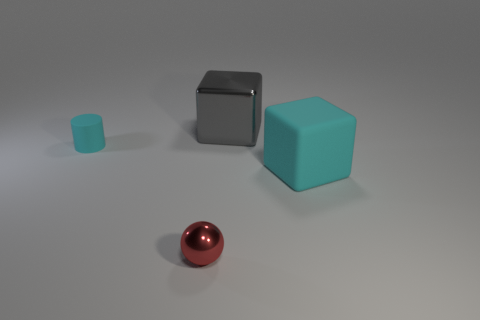What number of other things are the same color as the tiny metal ball?
Offer a terse response. 0. There is a object that is both on the right side of the small rubber cylinder and behind the rubber cube; what is its color?
Your response must be concise. Gray. There is a metallic thing that is right of the metal thing that is to the left of the big thing that is to the left of the big matte thing; what size is it?
Your response must be concise. Large. How many things are either cyan rubber things that are to the left of the large gray metallic thing or metallic objects that are on the right side of the small red object?
Your answer should be compact. 2. The large gray metal object has what shape?
Your answer should be very brief. Cube. What number of other things are made of the same material as the tiny cyan thing?
Give a very brief answer. 1. What is the size of the gray object that is the same shape as the big cyan object?
Your answer should be compact. Large. What material is the big thing in front of the metal object that is behind the cyan thing that is to the right of the red metallic object?
Provide a succinct answer. Rubber. Are there any small cyan matte objects?
Keep it short and to the point. Yes. There is a small rubber cylinder; is its color the same as the matte object that is on the right side of the tiny metallic thing?
Give a very brief answer. Yes. 